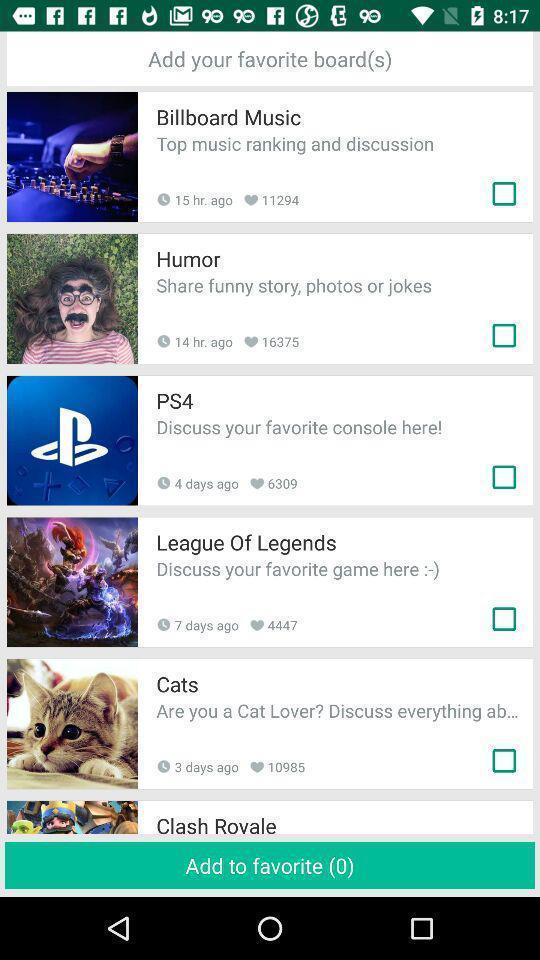What can you discern from this picture? Page for adding favorite posts of different categories. 